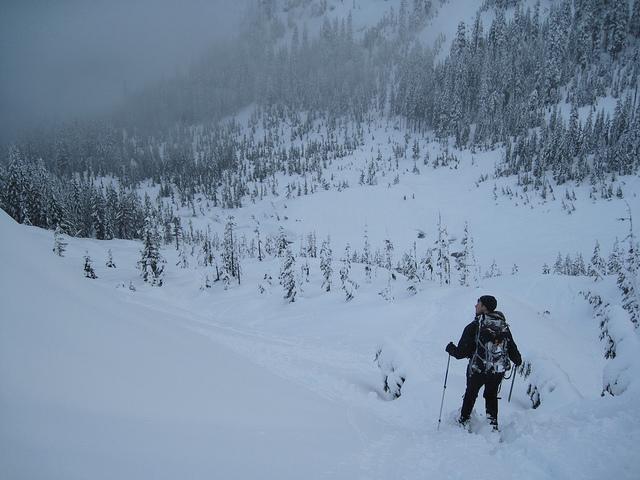Which direction are the skiers going?
Write a very short answer. Downhill. Does the man have a backpack?
Concise answer only. Yes. What is on the ground?
Keep it brief. Snow. Are any animals visible?
Be succinct. No. 